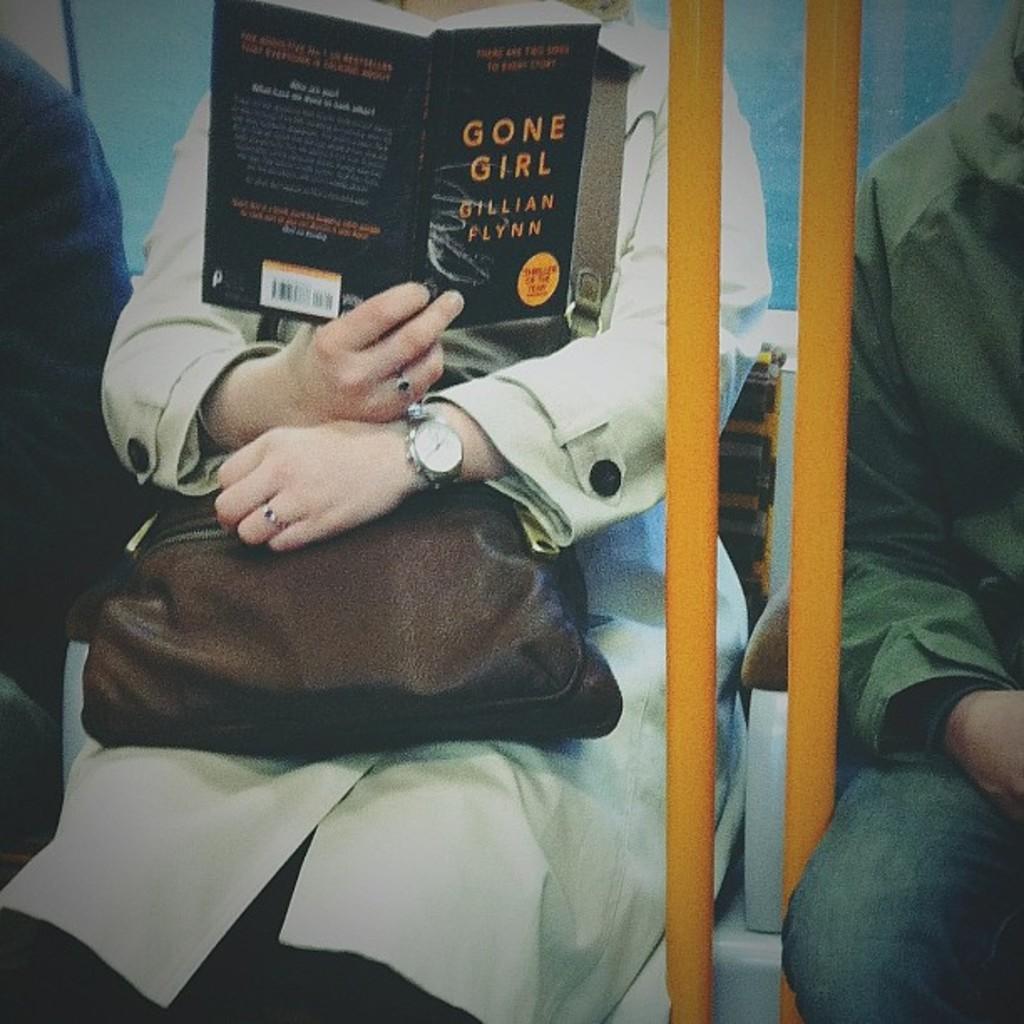Who's the author of the book?
Your answer should be compact. Gillian flynn. 